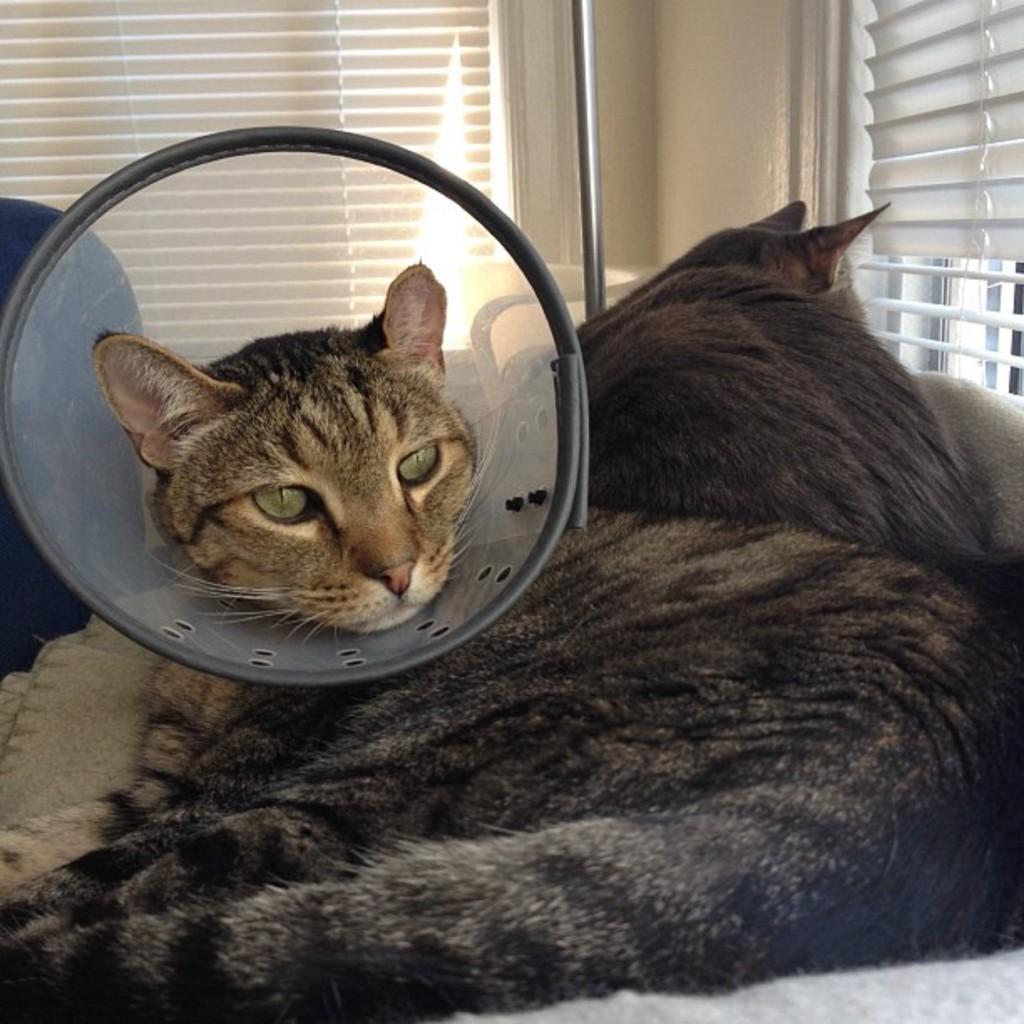How would you summarize this image in a sentence or two? In this image there is a cat placed her head in an object, beside this cat there is another cat. In the background there are windows and a rod. 